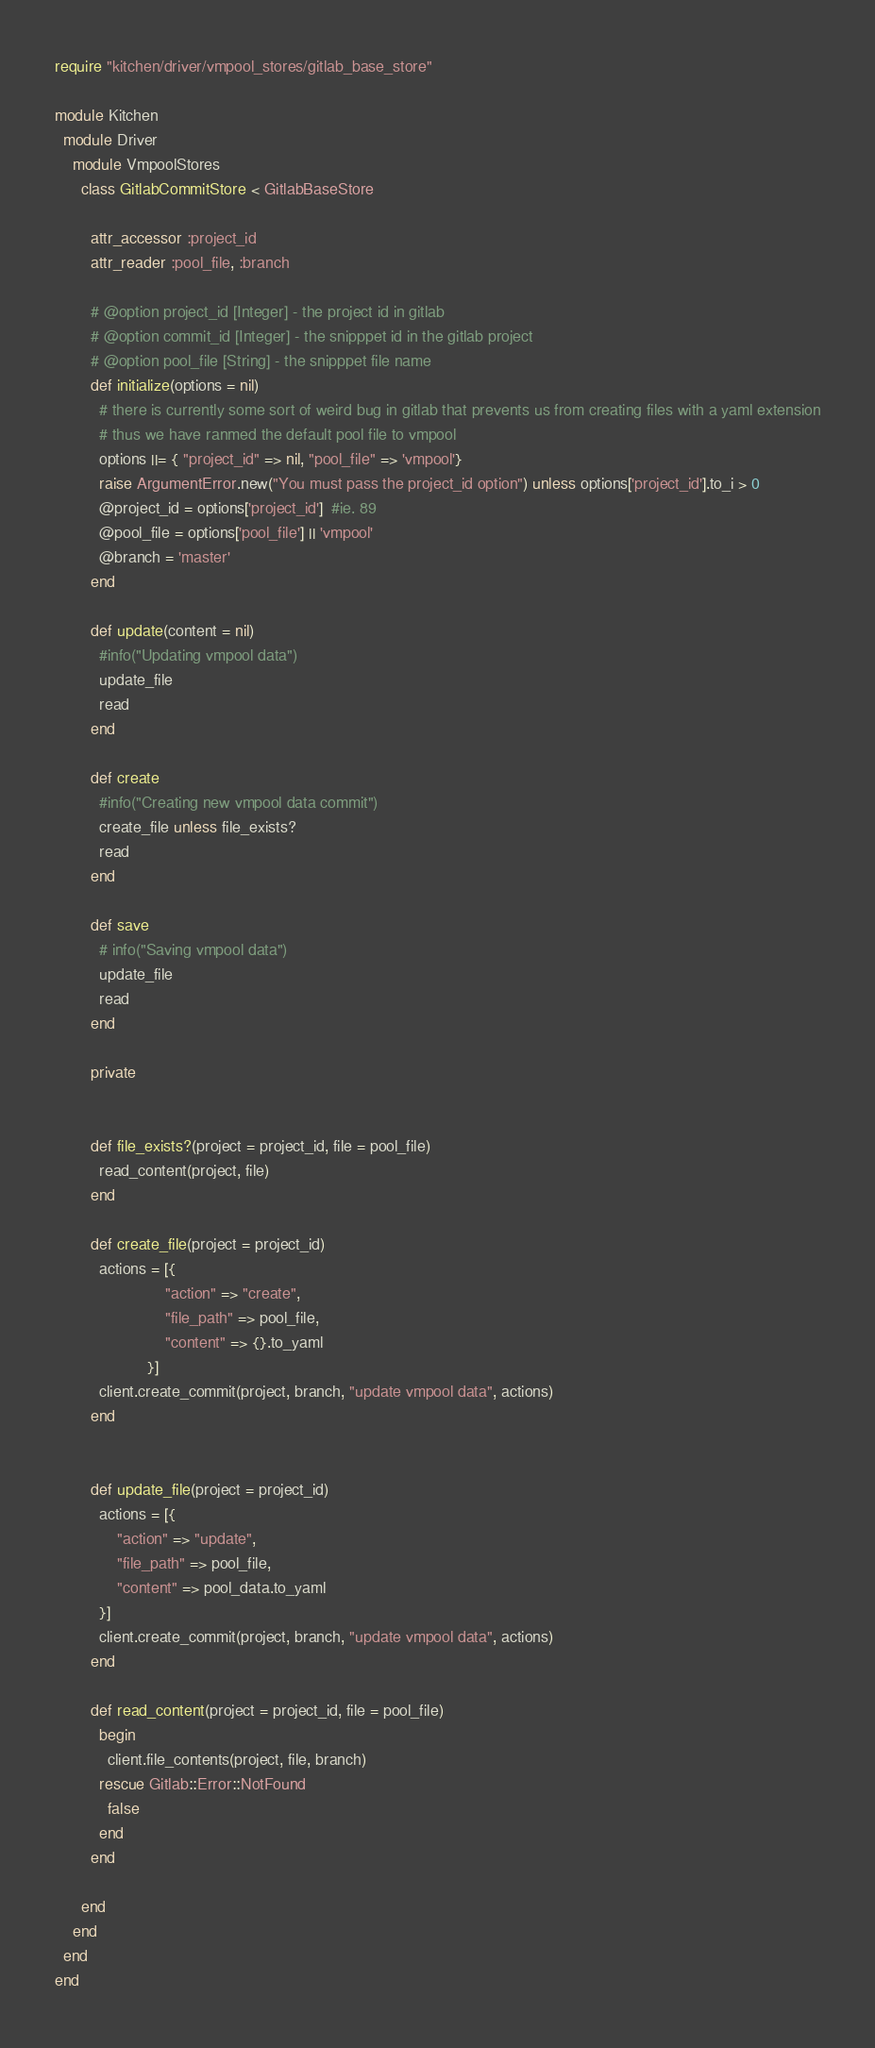<code> <loc_0><loc_0><loc_500><loc_500><_Ruby_>require "kitchen/driver/vmpool_stores/gitlab_base_store"

module Kitchen
  module Driver
    module VmpoolStores
      class GitlabCommitStore < GitlabBaseStore

        attr_accessor :project_id
        attr_reader :pool_file, :branch

        # @option project_id [Integer] - the project id in gitlab
        # @option commit_id [Integer] - the snipppet id in the gitlab project
        # @option pool_file [String] - the snipppet file name
        def initialize(options = nil)
          # there is currently some sort of weird bug in gitlab that prevents us from creating files with a yaml extension
          # thus we have ranmed the default pool file to vmpool
          options ||= { "project_id" => nil, "pool_file" => 'vmpool'}
          raise ArgumentError.new("You must pass the project_id option") unless options['project_id'].to_i > 0
          @project_id = options['project_id']  #ie. 89
          @pool_file = options['pool_file'] || 'vmpool'
          @branch = 'master'
        end

        def update(content = nil)
          #info("Updating vmpool data")
          update_file
          read
        end

        def create
          #info("Creating new vmpool data commit")
          create_file unless file_exists?
          read
        end

        def save
          # info("Saving vmpool data")
          update_file
          read
        end

        private


        def file_exists?(project = project_id, file = pool_file)
          read_content(project, file)
        end

        def create_file(project = project_id)
          actions = [{
                         "action" => "create",
                         "file_path" => pool_file,
                         "content" => {}.to_yaml
                     }]
          client.create_commit(project, branch, "update vmpool data", actions)
        end


        def update_file(project = project_id)
          actions = [{
              "action" => "update",
              "file_path" => pool_file,
              "content" => pool_data.to_yaml
          }]
          client.create_commit(project, branch, "update vmpool data", actions)
        end

        def read_content(project = project_id, file = pool_file)
          begin
            client.file_contents(project, file, branch)
          rescue Gitlab::Error::NotFound
            false
          end
        end

      end
    end
  end
end
</code> 